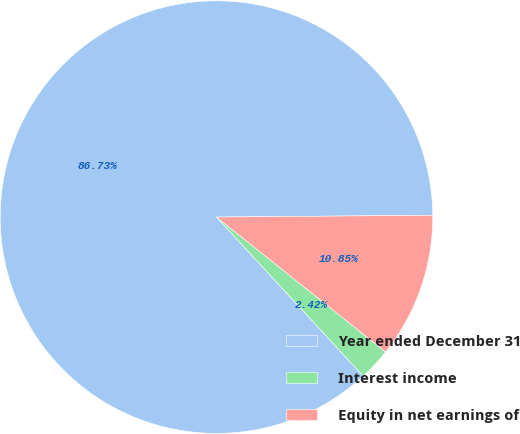Convert chart. <chart><loc_0><loc_0><loc_500><loc_500><pie_chart><fcel>Year ended December 31<fcel>Interest income<fcel>Equity in net earnings of<nl><fcel>86.72%<fcel>2.42%<fcel>10.85%<nl></chart> 